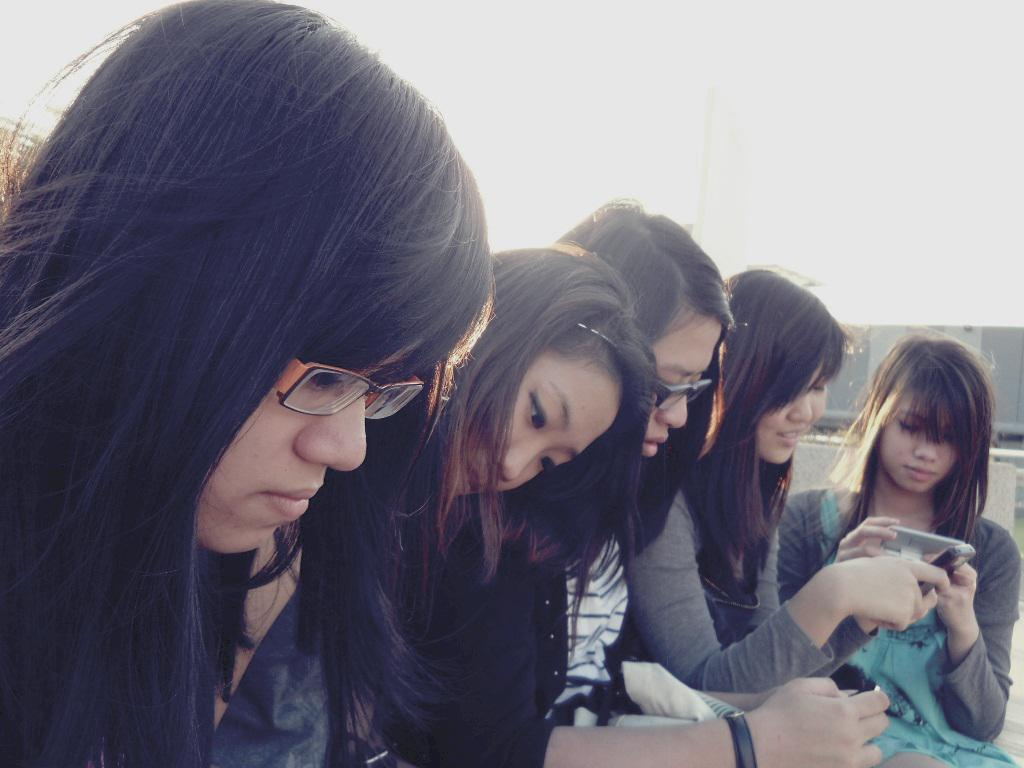What can be seen on the path in the image? There are groups of people on the path. What are some people doing in the image? Some people are holding mobiles. What is located behind the people in the image? There is an object behind the people. What is visible in the background of the image? The sky is visible in the image. What type of cactus can be seen growing on the path in the image? There is no cactus present in the image; the path is occupied by groups of people. What flavor of cake is being served to the people in the image? There is no cake present in the image; the people are holding mobiles. 